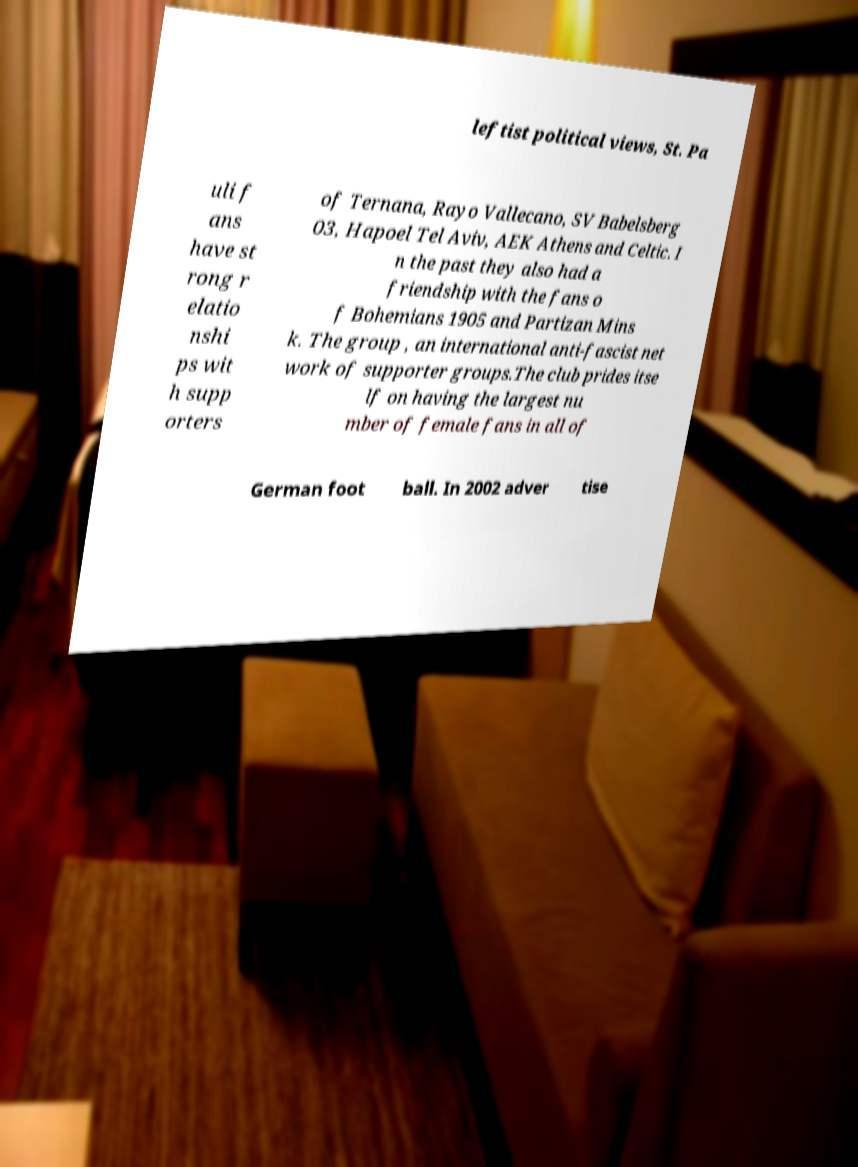Please read and relay the text visible in this image. What does it say? leftist political views, St. Pa uli f ans have st rong r elatio nshi ps wit h supp orters of Ternana, Rayo Vallecano, SV Babelsberg 03, Hapoel Tel Aviv, AEK Athens and Celtic. I n the past they also had a friendship with the fans o f Bohemians 1905 and Partizan Mins k. The group , an international anti-fascist net work of supporter groups.The club prides itse lf on having the largest nu mber of female fans in all of German foot ball. In 2002 adver tise 